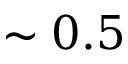<formula> <loc_0><loc_0><loc_500><loc_500>\sim 0 . 5</formula> 